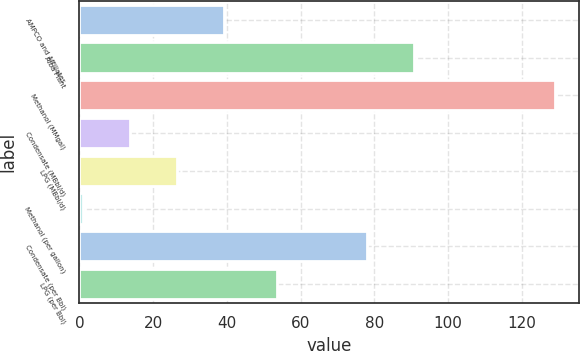<chart> <loc_0><loc_0><loc_500><loc_500><bar_chart><fcel>AMPCO and Affiliates<fcel>Alba Plant<fcel>Methanol (MMgal)<fcel>Condensate (MBbl/d)<fcel>LPG (MBbl/d)<fcel>Methanol (per gallon)<fcel>Condensate (per Bbl)<fcel>LPG (per Bbl)<nl><fcel>39.3<fcel>90.8<fcel>129<fcel>13.66<fcel>26.48<fcel>0.84<fcel>77.98<fcel>53.68<nl></chart> 